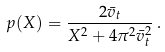<formula> <loc_0><loc_0><loc_500><loc_500>p ( X ) = \frac { 2 \bar { v } _ { t } } { X ^ { 2 } + 4 \pi ^ { 2 } \bar { v } _ { t } ^ { 2 } } \, .</formula> 